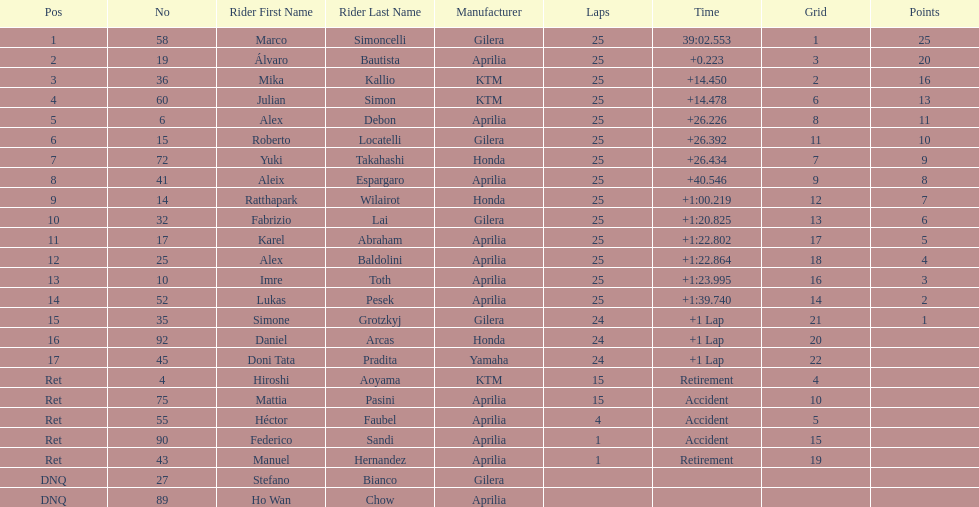Did marco simoncelli or alvaro bautista held rank 1? Marco Simoncelli. Could you parse the entire table as a dict? {'header': ['Pos', 'No', 'Rider First Name', 'Rider Last Name', 'Manufacturer', 'Laps', 'Time', 'Grid', 'Points'], 'rows': [['1', '58', 'Marco', 'Simoncelli', 'Gilera', '25', '39:02.553', '1', '25'], ['2', '19', 'Álvaro', 'Bautista', 'Aprilia', '25', '+0.223', '3', '20'], ['3', '36', 'Mika', 'Kallio', 'KTM', '25', '+14.450', '2', '16'], ['4', '60', 'Julian', 'Simon', 'KTM', '25', '+14.478', '6', '13'], ['5', '6', 'Alex', 'Debon', 'Aprilia', '25', '+26.226', '8', '11'], ['6', '15', 'Roberto', 'Locatelli', 'Gilera', '25', '+26.392', '11', '10'], ['7', '72', 'Yuki', 'Takahashi', 'Honda', '25', '+26.434', '7', '9'], ['8', '41', 'Aleix', 'Espargaro', 'Aprilia', '25', '+40.546', '9', '8'], ['9', '14', 'Ratthapark', 'Wilairot', 'Honda', '25', '+1:00.219', '12', '7'], ['10', '32', 'Fabrizio', 'Lai', 'Gilera', '25', '+1:20.825', '13', '6'], ['11', '17', 'Karel', 'Abraham', 'Aprilia', '25', '+1:22.802', '17', '5'], ['12', '25', 'Alex', 'Baldolini', 'Aprilia', '25', '+1:22.864', '18', '4'], ['13', '10', 'Imre', 'Toth', 'Aprilia', '25', '+1:23.995', '16', '3'], ['14', '52', 'Lukas', 'Pesek', 'Aprilia', '25', '+1:39.740', '14', '2'], ['15', '35', 'Simone', 'Grotzkyj', 'Gilera', '24', '+1 Lap', '21', '1'], ['16', '92', 'Daniel', 'Arcas', 'Honda', '24', '+1 Lap', '20', ''], ['17', '45', 'Doni Tata', 'Pradita', 'Yamaha', '24', '+1 Lap', '22', ''], ['Ret', '4', 'Hiroshi', 'Aoyama', 'KTM', '15', 'Retirement', '4', ''], ['Ret', '75', 'Mattia', 'Pasini', 'Aprilia', '15', 'Accident', '10', ''], ['Ret', '55', 'Héctor', 'Faubel', 'Aprilia', '4', 'Accident', '5', ''], ['Ret', '90', 'Federico', 'Sandi', 'Aprilia', '1', 'Accident', '15', ''], ['Ret', '43', 'Manuel', 'Hernandez', 'Aprilia', '1', 'Retirement', '19', ''], ['DNQ', '27', 'Stefano', 'Bianco', 'Gilera', '', '', '', ''], ['DNQ', '89', 'Ho Wan', 'Chow', 'Aprilia', '', '', '', '']]} 